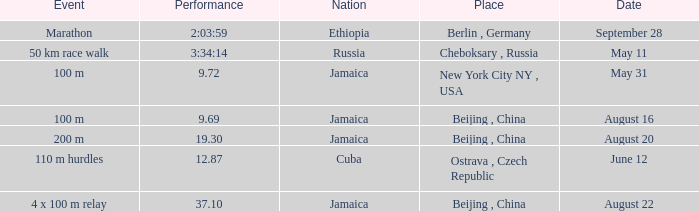What is the Place associated with Cuba? Ostrava , Czech Republic. 